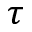<formula> <loc_0><loc_0><loc_500><loc_500>\tau</formula> 